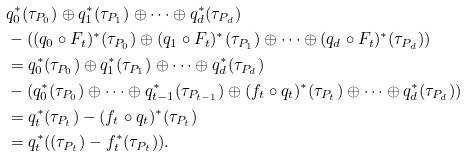Convert formula to latex. <formula><loc_0><loc_0><loc_500><loc_500>& q _ { 0 } ^ { \ast } ( \tau _ { P _ { 0 } } ) \oplus q _ { 1 } ^ { \ast } ( \tau _ { P _ { 1 } } ) \oplus \cdots \oplus q _ { d } ^ { \ast } ( \tau _ { P _ { d } } ) \\ & - ( ( q _ { 0 } \circ F _ { t } ) ^ { \ast } ( \tau _ { P _ { 0 } } ) \oplus ( q _ { 1 } \circ F _ { t } ) ^ { \ast } ( \tau _ { P _ { 1 } } ) \oplus \cdots \oplus ( q _ { d } \circ F _ { t } ) ^ { \ast } ( \tau _ { P _ { d } } ) ) \\ & = q _ { 0 } ^ { \ast } ( \tau _ { P _ { 0 } } ) \oplus q _ { 1 } ^ { \ast } ( \tau _ { P _ { 1 } } ) \oplus \cdots \oplus q _ { d } ^ { \ast } ( \tau _ { P _ { d } } ) \\ & - ( q _ { 0 } ^ { \ast } ( \tau _ { P _ { 0 } } ) \oplus \cdots \oplus q _ { t - 1 } ^ { \ast } ( \tau _ { P _ { t - 1 } } ) \oplus ( f _ { t } \circ q _ { t } ) ^ { \ast } ( \tau _ { P _ { t } } ) \oplus \cdots \oplus q _ { d } ^ { \ast } ( \tau _ { P _ { d } } ) ) \\ & = q _ { t } ^ { \ast } ( \tau _ { P _ { t } } ) - ( f _ { t } \circ q _ { t } ) ^ { \ast } ( \tau _ { P _ { t } } ) \\ & = q _ { t } ^ { \ast } ( ( \tau _ { P _ { t } } ) - f _ { t } ^ { \ast } ( \tau _ { P _ { t } } ) ) .</formula> 